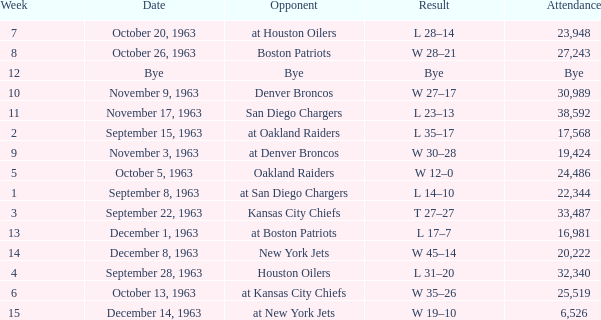Which Opponent has a Date of november 17, 1963? San Diego Chargers. 